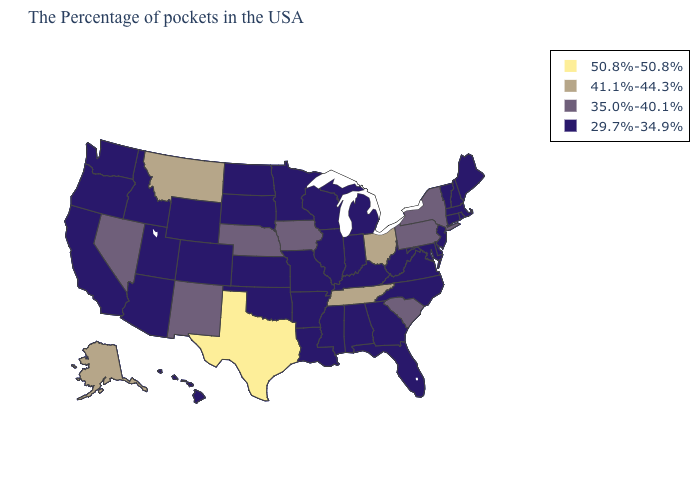Name the states that have a value in the range 41.1%-44.3%?
Be succinct. Ohio, Tennessee, Montana, Alaska. What is the value of Pennsylvania?
Concise answer only. 35.0%-40.1%. What is the value of Arizona?
Be succinct. 29.7%-34.9%. Among the states that border Louisiana , which have the lowest value?
Concise answer only. Mississippi, Arkansas. What is the lowest value in states that border Mississippi?
Quick response, please. 29.7%-34.9%. What is the lowest value in states that border Mississippi?
Write a very short answer. 29.7%-34.9%. How many symbols are there in the legend?
Concise answer only. 4. What is the lowest value in the Northeast?
Short answer required. 29.7%-34.9%. Name the states that have a value in the range 35.0%-40.1%?
Concise answer only. New York, Pennsylvania, South Carolina, Iowa, Nebraska, New Mexico, Nevada. Which states have the lowest value in the West?
Keep it brief. Wyoming, Colorado, Utah, Arizona, Idaho, California, Washington, Oregon, Hawaii. What is the value of Indiana?
Write a very short answer. 29.7%-34.9%. Does Pennsylvania have the same value as Nebraska?
Be succinct. Yes. Does Idaho have a lower value than New York?
Give a very brief answer. Yes. Which states have the highest value in the USA?
Short answer required. Texas. 